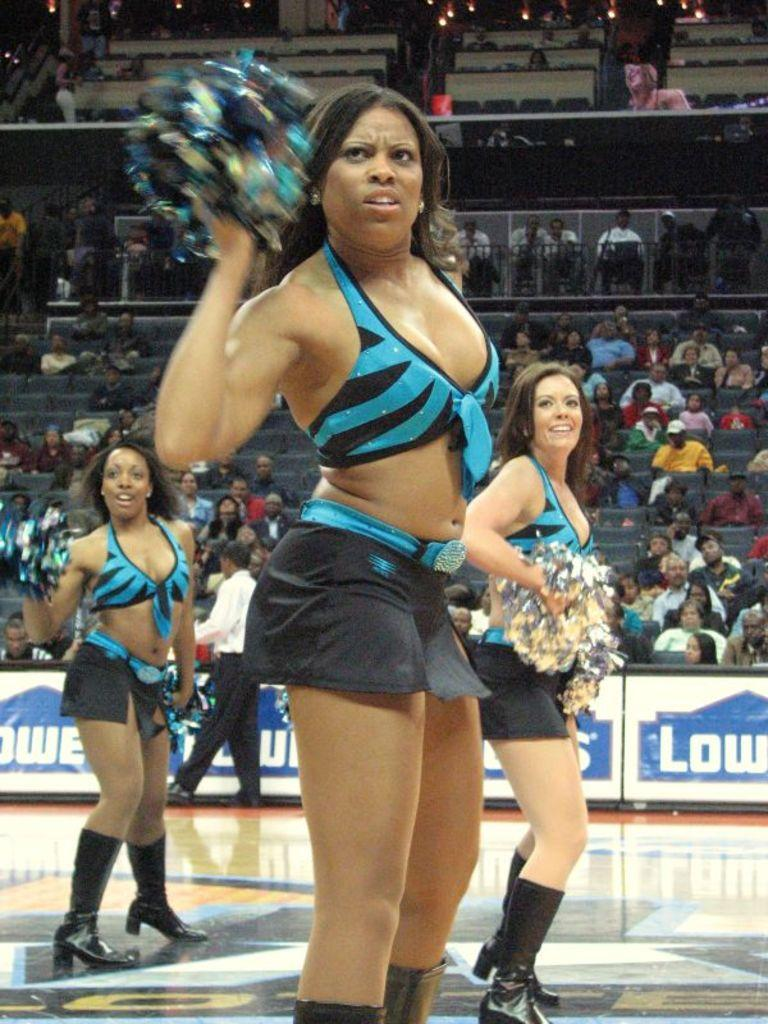What type of people are featured in the image? There are cheerleading girls in the image. What can be seen in the background of the image? There is an audience in the background of the image. What is the format of the image? The image is a hoarding. What is visible at the top of the image? There are lights visible at the top of the image. What type of sponge is being used by the cheerleading girls in the image? There is no sponge present in the image; the cheerleading girls are performing without any sponge-related props or equipment. 